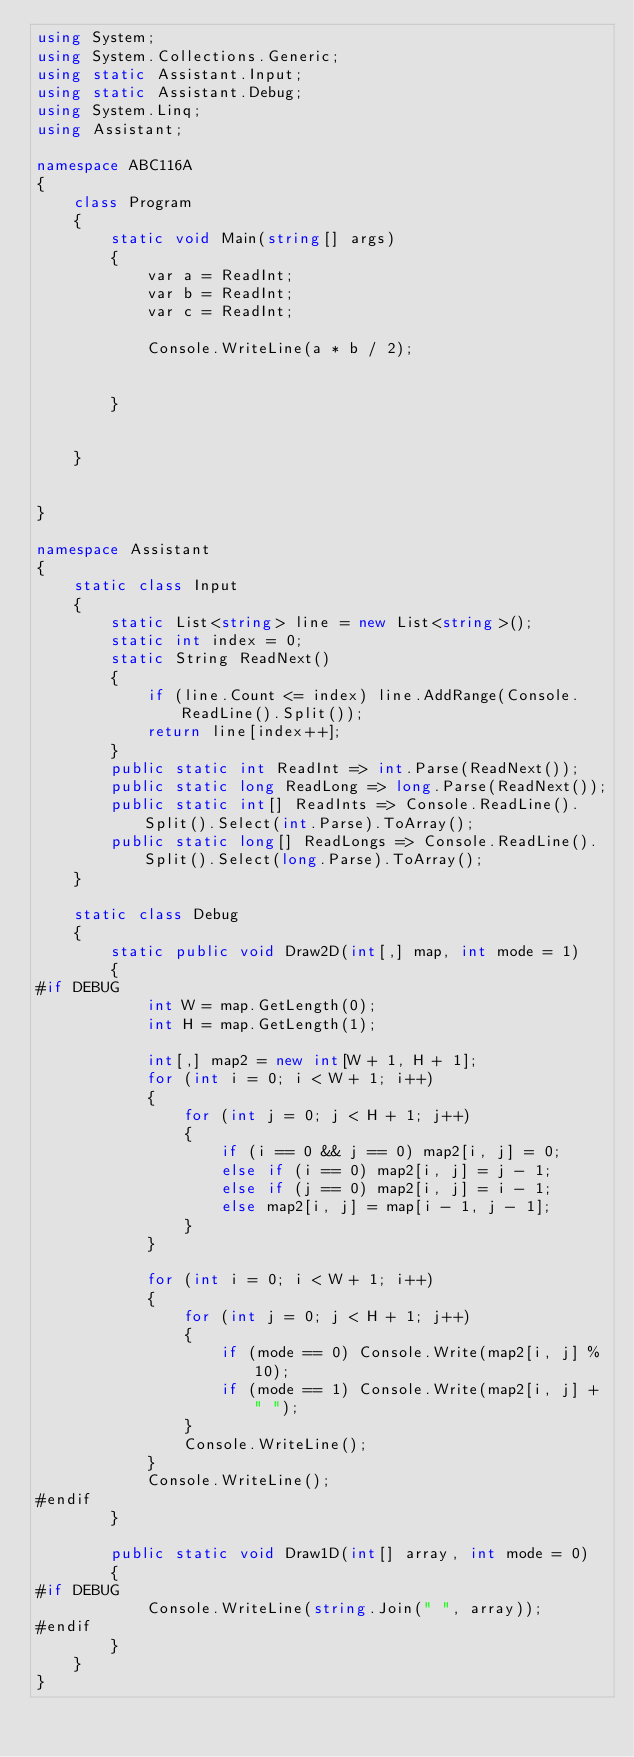<code> <loc_0><loc_0><loc_500><loc_500><_C#_>using System;
using System.Collections.Generic;
using static Assistant.Input;
using static Assistant.Debug;
using System.Linq;
using Assistant;

namespace ABC116A
{
    class Program
    {
        static void Main(string[] args)
        {
            var a = ReadInt;
            var b = ReadInt;
            var c = ReadInt;

            Console.WriteLine(a * b / 2);


        }


    }


}

namespace Assistant
{
    static class Input
    {
        static List<string> line = new List<string>();
        static int index = 0;
        static String ReadNext()
        {
            if (line.Count <= index) line.AddRange(Console.ReadLine().Split());
            return line[index++];
        }
        public static int ReadInt => int.Parse(ReadNext());
        public static long ReadLong => long.Parse(ReadNext());
        public static int[] ReadInts => Console.ReadLine().Split().Select(int.Parse).ToArray();
        public static long[] ReadLongs => Console.ReadLine().Split().Select(long.Parse).ToArray();
    }

    static class Debug
    {
        static public void Draw2D(int[,] map, int mode = 1)
        {
#if DEBUG
            int W = map.GetLength(0);
            int H = map.GetLength(1);

            int[,] map2 = new int[W + 1, H + 1];
            for (int i = 0; i < W + 1; i++)
            {
                for (int j = 0; j < H + 1; j++)
                {
                    if (i == 0 && j == 0) map2[i, j] = 0;
                    else if (i == 0) map2[i, j] = j - 1;
                    else if (j == 0) map2[i, j] = i - 1;
                    else map2[i, j] = map[i - 1, j - 1];
                }
            }

            for (int i = 0; i < W + 1; i++)
            {
                for (int j = 0; j < H + 1; j++)
                {
                    if (mode == 0) Console.Write(map2[i, j] % 10);
                    if (mode == 1) Console.Write(map2[i, j] + " ");
                }
                Console.WriteLine();
            }
            Console.WriteLine();
#endif
        }

        public static void Draw1D(int[] array, int mode = 0)
        {
#if DEBUG
            Console.WriteLine(string.Join(" ", array));
#endif
        }
    }
}
</code> 